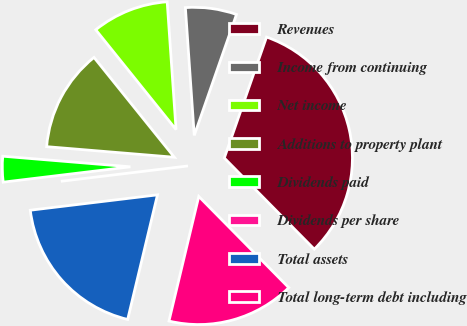Convert chart to OTSL. <chart><loc_0><loc_0><loc_500><loc_500><pie_chart><fcel>Revenues<fcel>Income from continuing<fcel>Net income<fcel>Additions to property plant<fcel>Dividends paid<fcel>Dividends per share<fcel>Total assets<fcel>Total long-term debt including<nl><fcel>32.26%<fcel>6.45%<fcel>9.68%<fcel>12.9%<fcel>3.23%<fcel>0.0%<fcel>19.35%<fcel>16.13%<nl></chart> 